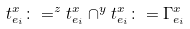<formula> <loc_0><loc_0><loc_500><loc_500>t ^ { x } _ { e _ { i } } \colon = ^ { z } t ^ { x } _ { e _ { i } } \cap ^ { y } t ^ { x } _ { e _ { i } } \colon = \Gamma ^ { x } _ { e _ { i } }</formula> 